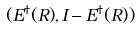<formula> <loc_0><loc_0><loc_500><loc_500>( E ^ { \dagger } ( R ) , I - E ^ { \dagger } ( R ) )</formula> 